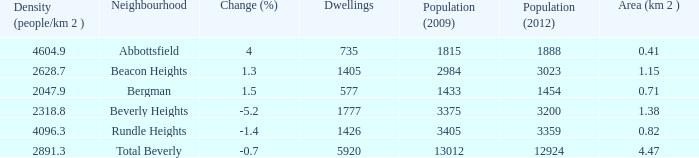What is the density of an area that is 1.38km and has a population more than 12924? 0.0. 